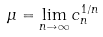<formula> <loc_0><loc_0><loc_500><loc_500>\mu = \lim _ { n \to \infty } c _ { n } ^ { 1 / n }</formula> 